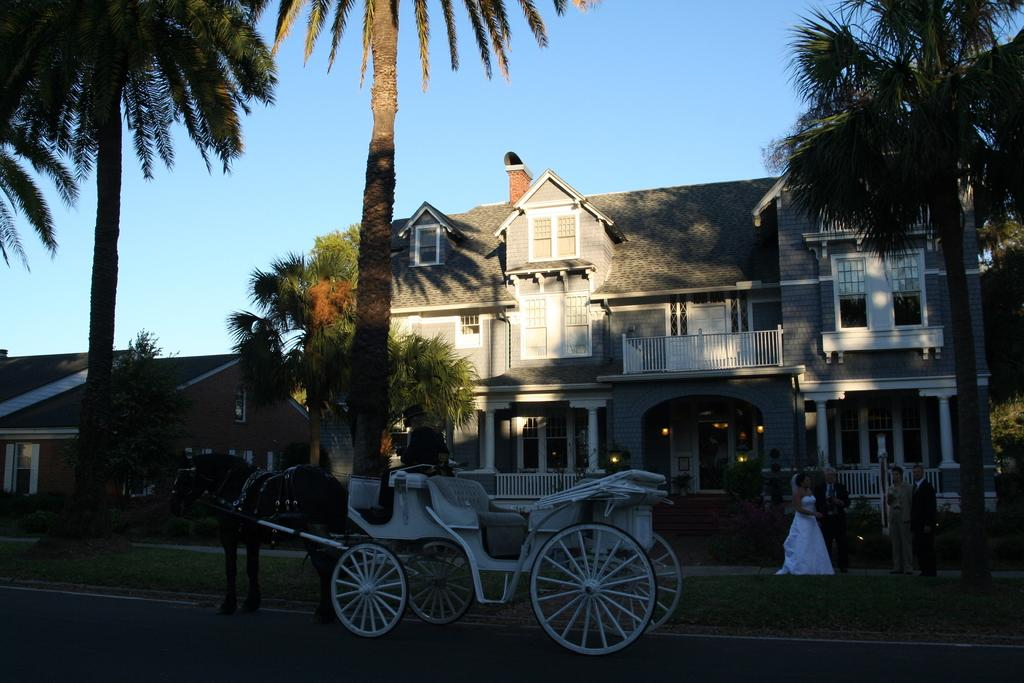What is happening in the image? There is a group of people in the image, and a man is seated on a horse cart. What can be seen in the background of the image? There are houses, trees, and lights visible in the background of the image. What type of horn is being played by the man in the image? There is no horn present in the image; the man is seated on a horse cart. Who is taking the picture of the group in the image? There is no camera or photographer present in the image, so it cannot be determined who is taking the picture. 